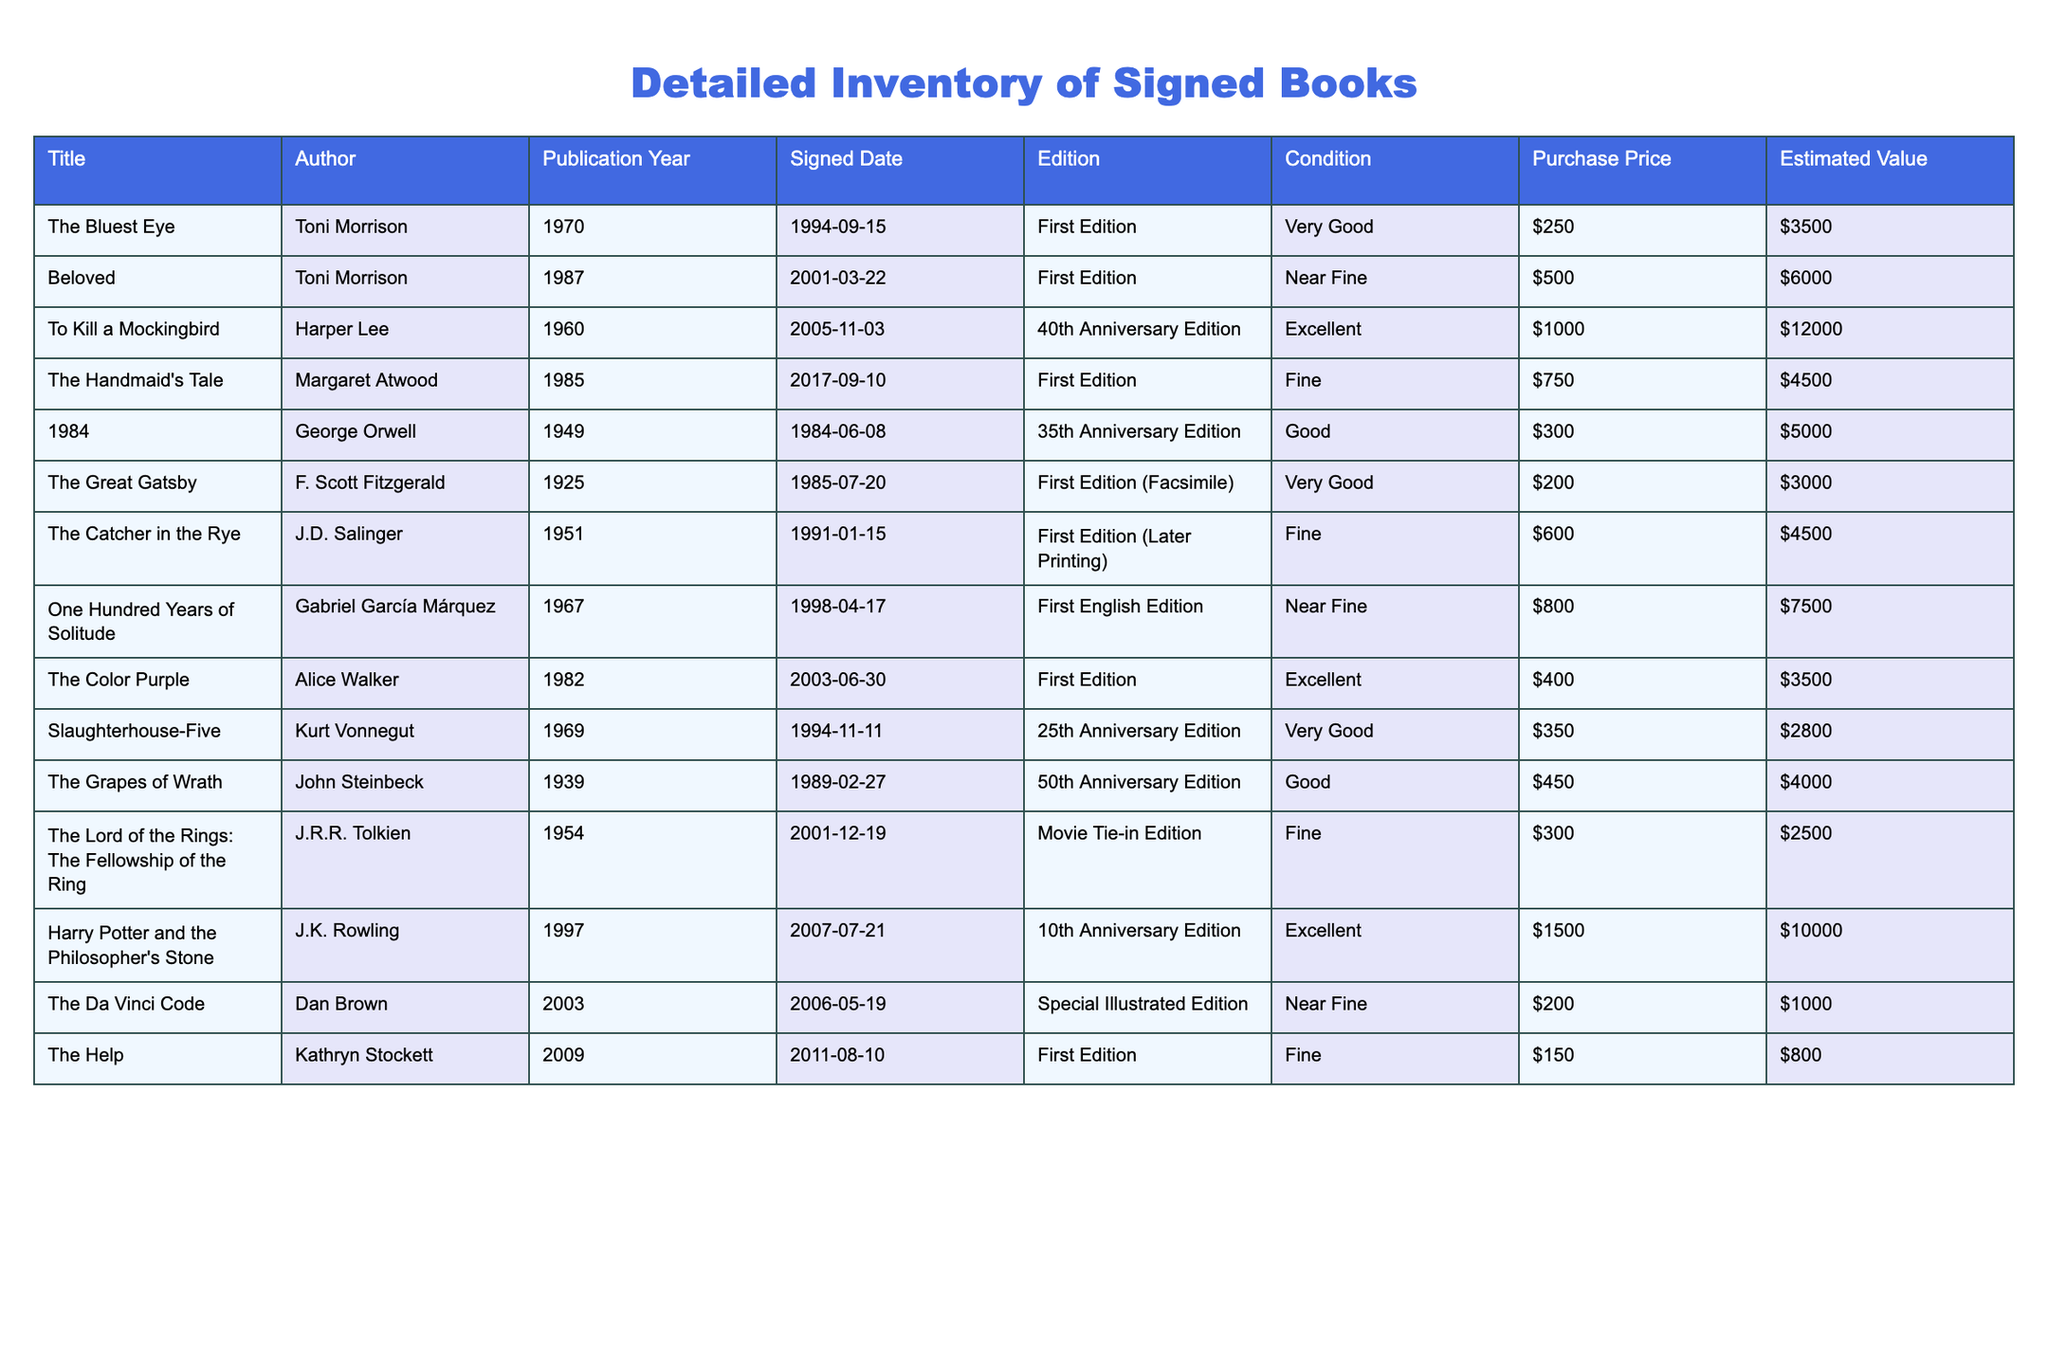What is the estimated value of "Beloved" by Toni Morrison? The estimated value of "Beloved" is provided directly in the table under the "Estimated Value" column. It shows $6000.
Answer: $6000 What is the signed date for "To Kill a Mockingbird"? By referring to the "Signed Date" column of the table, it shows that "To Kill a Mockingbird" was signed on November 3, 2005.
Answer: November 3, 2005 How many books have a condition rated as "Excellent"? From the table, we can count the entries with a condition listed as "Excellent." There are three books: "The Color Purple," "To Kill a Mockingbird," and "Harry Potter and the Philosopher's Stone."
Answer: 3 What is the total purchase price of all signed books in the inventory? We sum the "Purchase Price" values from the table: $250 + $500 + $1000 + $750 + $300 + $200 + $600 + $800 + $400 + $350 + $450 + $300 + $1500 + $200 + $150 = $7550.
Answer: $7550 Is "The Great Gatsby" the oldest book in the collection? We can examine the "Publication Year" of all books and find that the oldest book is "The Great Gatsby," published in 1925. Thus, it is the oldest in the collection.
Answer: Yes What is the average estimated value of the books in "Very Good" condition? The books in "Very Good" condition are "The Bluest Eye," "The Great Gatsby," and "Slaughterhouse-Five" with estimated values of $3500, $3000, and $2800, respectively. Their total is $3500 + $3000 + $2800 = $9300, and we divide by 3 (the number of books) to get the average: $9300 / 3 = $3100.
Answer: $3100 How many first editions are signed in the collection? We can locate the books labeled as "First Edition" in the "Edition" column and count them. The titles are "The Bluest Eye," "Beloved," "The Handmaid's Tale," "The Color Purple," and "Harry Potter and the Philosopher's Stone," amounting to five in total.
Answer: 5 What is the difference in purchase price between "Harry Potter and the Philosopher's Stone" and "The Da Vinci Code"? We find the purchase price of "Harry Potter" at $1500 and "The Da Vinci Code" at $200. The difference is $1500 - $200 = $1300.
Answer: $1300 Are there any signed books with a publication year after 2000? By reviewing the "Publication Year" column, the signed books "The Help" (2009) and "The Da Vinci Code" (2003) are published after 2000, confirming there are such books in the collection.
Answer: Yes What is the estimated value of the oldest book in the collection? We identified "The Great Gatsby" as the oldest book published in 1925. Looking at the table, it has an estimated value of $3000.
Answer: $3000 What percentage of the books are in "Near Fine" condition? There are 2 books in "Near Fine" condition: "Beloved" and "The Da Vinci Code." With a total of 14 books, the percentage is calculated as (2/14) * 100 = approximately 14.29%.
Answer: 14.29% 